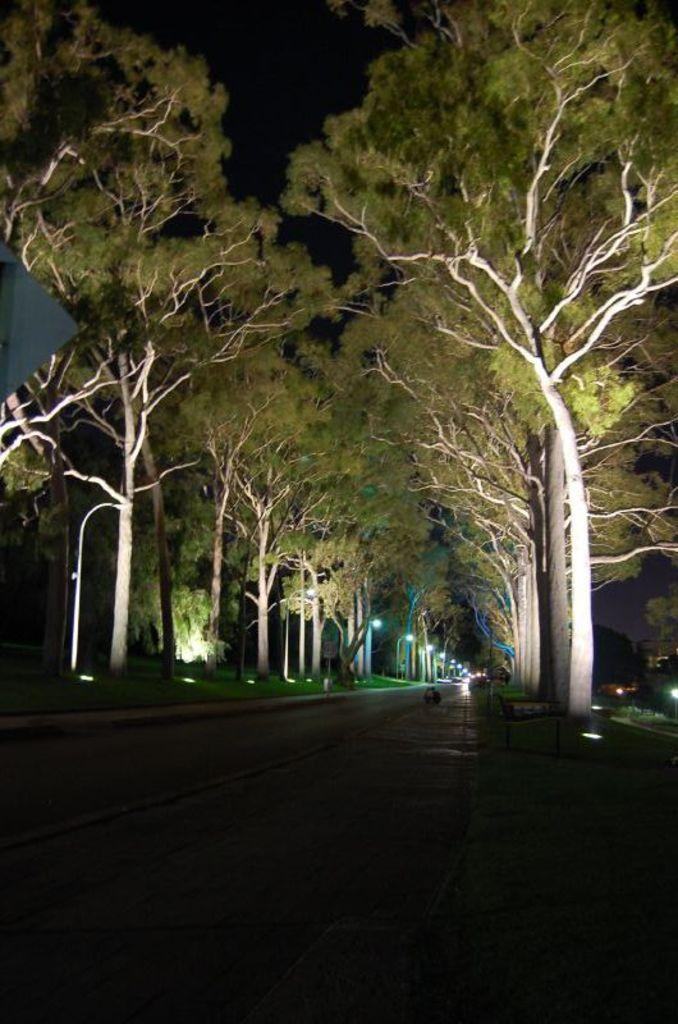What type of natural elements can be seen in the image? There are trees in the image. What man-made structures are present in the image? There are poles in the image. What objects provide illumination in the image? There are lights in the image. What hobbies are the trees participating in within the image? Trees do not have hobbies, as they are inanimate objects. What type of suit is the pole wearing in the image? Poles do not wear suits, as they are inanimate objects. 